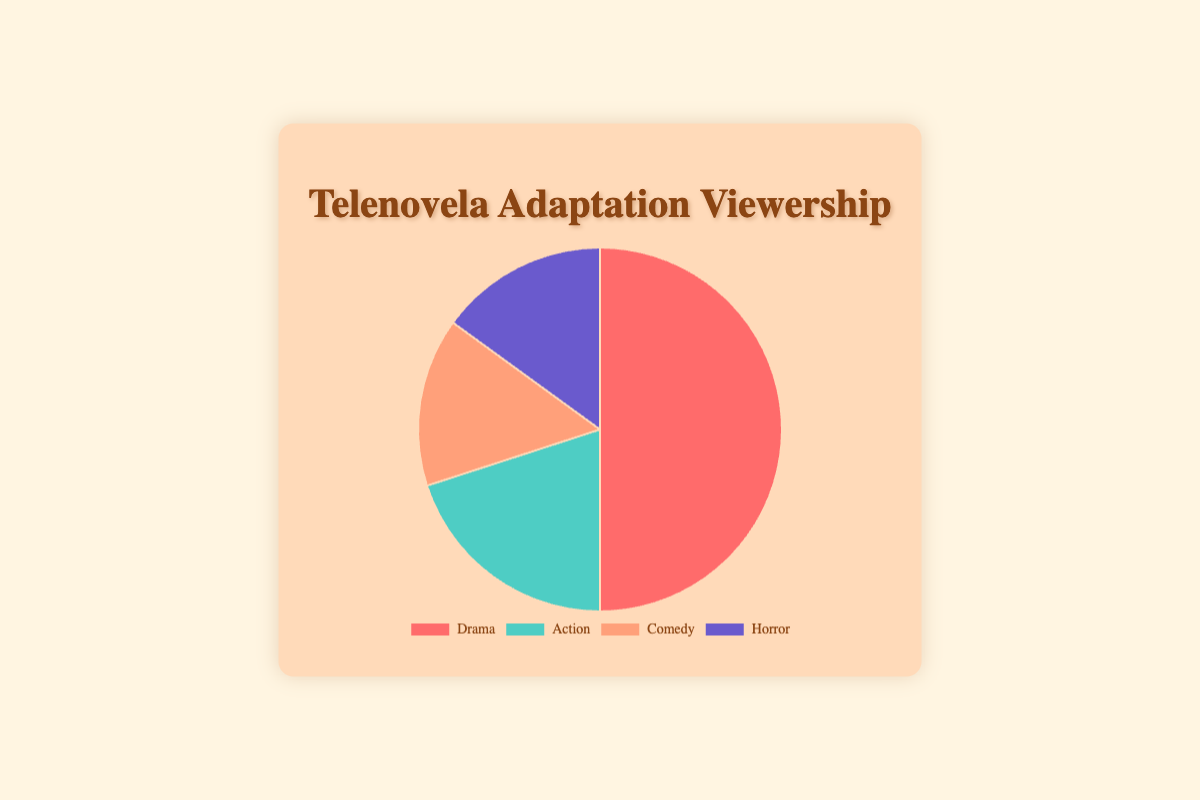What is the most popular type of telenovela adaptation? The figure shows the viewership shares of different telenovela adaptation types, and the type with the largest slice represents the most popular. In this case, Drama has the highest percentage.
Answer: Drama What are the combined viewership shares of Comedy and Horror adaptations? To find the combined viewership shares, add the percentage for Comedy (15%) and Horror (15%). Total = 15% + 15%.
Answer: 30% Which adaptation type is least popular? By looking at the smallest slices of the pie chart, we can see Comedy and Horror have equal and the smallest shares. Therefore, both Comedy and Horror are the least popular.
Answer: Comedy and Horror How does the viewership share of Action compare to that of Horror? The Action share is 20%, and the Horror share is 15%. Since 20% is greater than 15%, Action has a larger viewership share than Horror.
Answer: Action has a larger share What is the difference in viewership share between Drama and Comedy adaptations? Subtract the viewership share of Comedy (15%) from Drama (50%). Difference = 50% - 15% = 35%.
Answer: 35% How many adaptation types have equal viewership shares? The Horror and Comedy slices of the pie chart are the same size, indicating they have equal viewership shares. Therefore, there are 2 types with equal viewership shares.
Answer: 2 What percentage of the total viewership is not Drama? Subtract the viewership share of Drama (50%) from the total (100%). Remaining percentage = 100% - 50% = 50%.
Answer: 50% If a new adaptation increases the Comedy viewership share by 10%, what would be the new share for Comedy? Current Comedy share is 15%. Adding 10% results in a new share of 15% + 10% = 25%.
Answer: 25% Which colors represent the Drama and Action adaptation types? The Drama slice is depicted with a red segment, and the Action slice is depicted with a teal segment.
Answer: Drama is red, Action is teal 